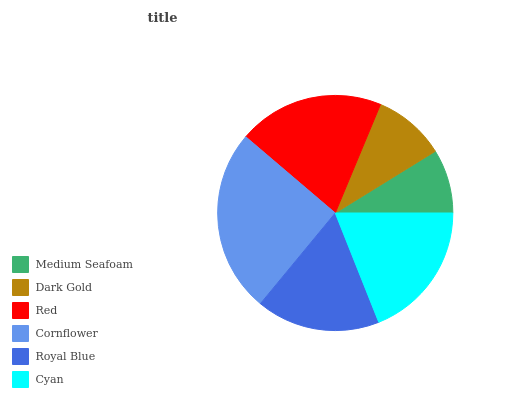Is Medium Seafoam the minimum?
Answer yes or no. Yes. Is Cornflower the maximum?
Answer yes or no. Yes. Is Dark Gold the minimum?
Answer yes or no. No. Is Dark Gold the maximum?
Answer yes or no. No. Is Dark Gold greater than Medium Seafoam?
Answer yes or no. Yes. Is Medium Seafoam less than Dark Gold?
Answer yes or no. Yes. Is Medium Seafoam greater than Dark Gold?
Answer yes or no. No. Is Dark Gold less than Medium Seafoam?
Answer yes or no. No. Is Cyan the high median?
Answer yes or no. Yes. Is Royal Blue the low median?
Answer yes or no. Yes. Is Cornflower the high median?
Answer yes or no. No. Is Medium Seafoam the low median?
Answer yes or no. No. 